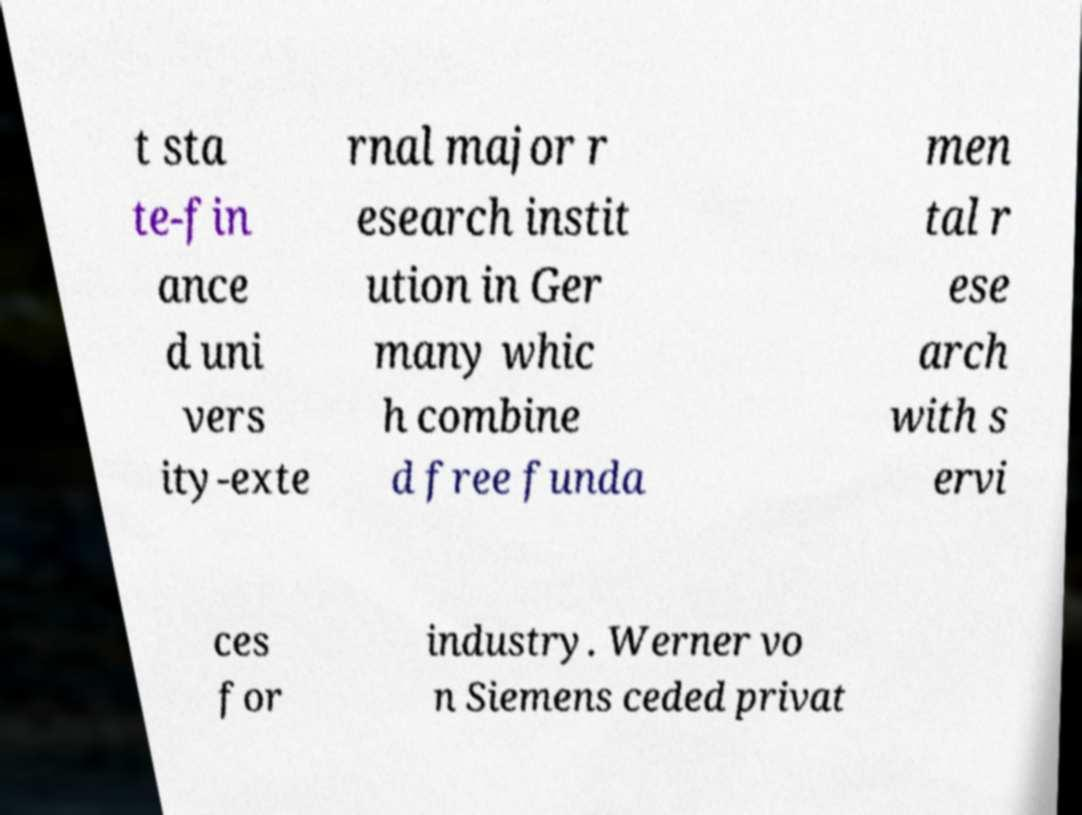What messages or text are displayed in this image? I need them in a readable, typed format. t sta te-fin ance d uni vers ity-exte rnal major r esearch instit ution in Ger many whic h combine d free funda men tal r ese arch with s ervi ces for industry. Werner vo n Siemens ceded privat 